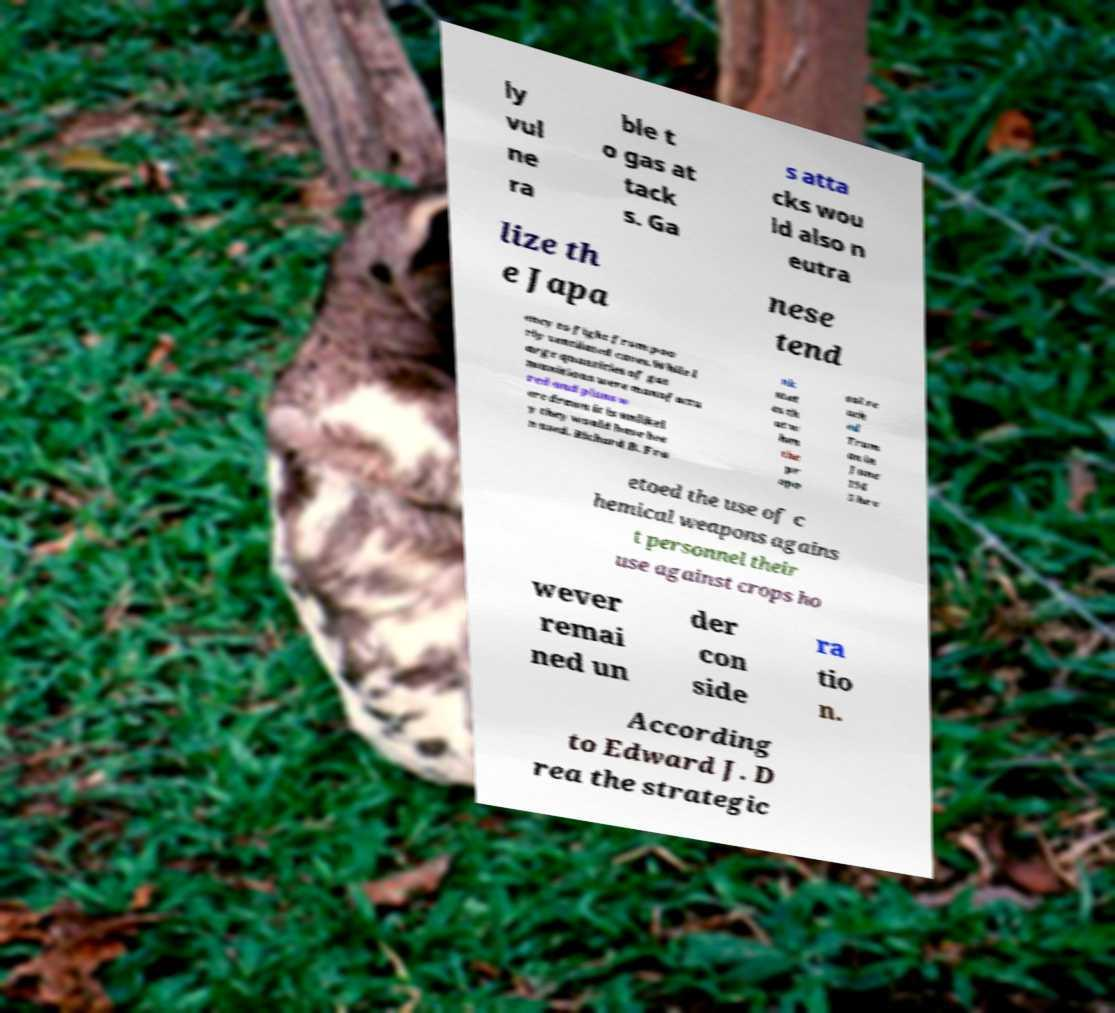Could you extract and type out the text from this image? ly vul ne ra ble t o gas at tack s. Ga s atta cks wou ld also n eutra lize th e Japa nese tend ency to fight from poo rly ventilated caves.While l arge quantities of gas munitions were manufactu red and plans w ere drawn it is unlikel y they would have bee n used. Richard B. Fra nk stat es th at w hen the pr opo sal re ach ed Trum an in June 194 5 he v etoed the use of c hemical weapons agains t personnel their use against crops ho wever remai ned un der con side ra tio n. According to Edward J. D rea the strategic 